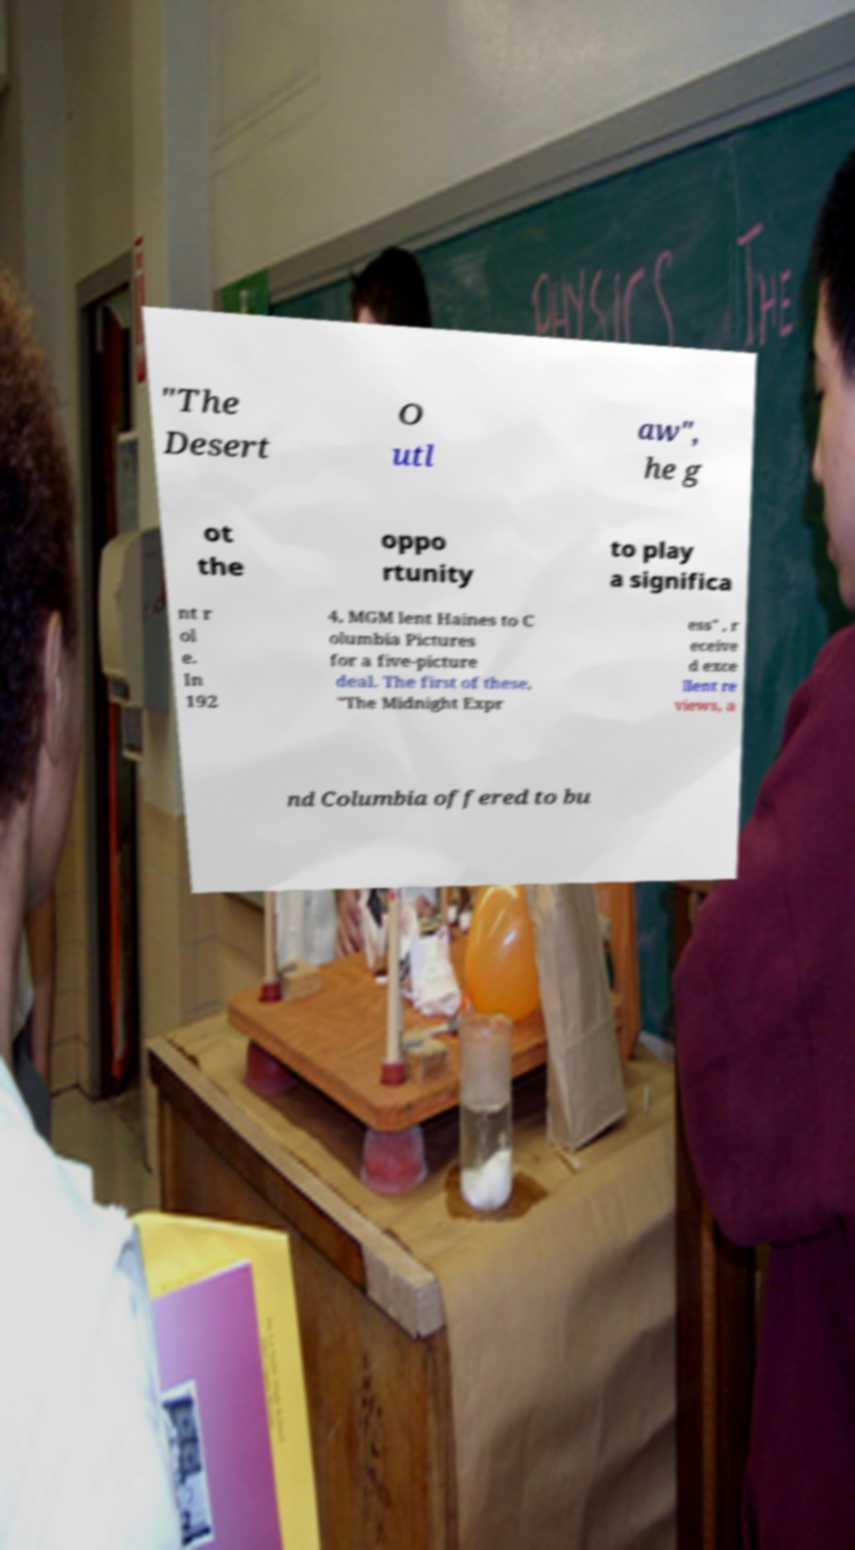Could you extract and type out the text from this image? "The Desert O utl aw", he g ot the oppo rtunity to play a significa nt r ol e. In 192 4, MGM lent Haines to C olumbia Pictures for a five-picture deal. The first of these, "The Midnight Expr ess" , r eceive d exce llent re views, a nd Columbia offered to bu 